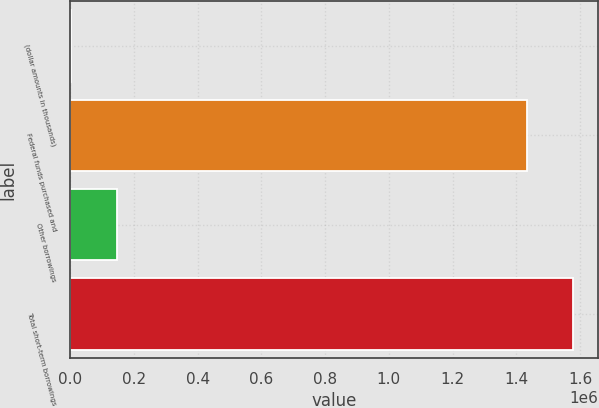Convert chart. <chart><loc_0><loc_0><loc_500><loc_500><bar_chart><fcel>(dollar amounts in thousands)<fcel>Federal funds purchased and<fcel>Other borrowings<fcel>Total short-term borrowings<nl><fcel>2011<fcel>1.43431e+06<fcel>145919<fcel>1.57822e+06<nl></chart> 